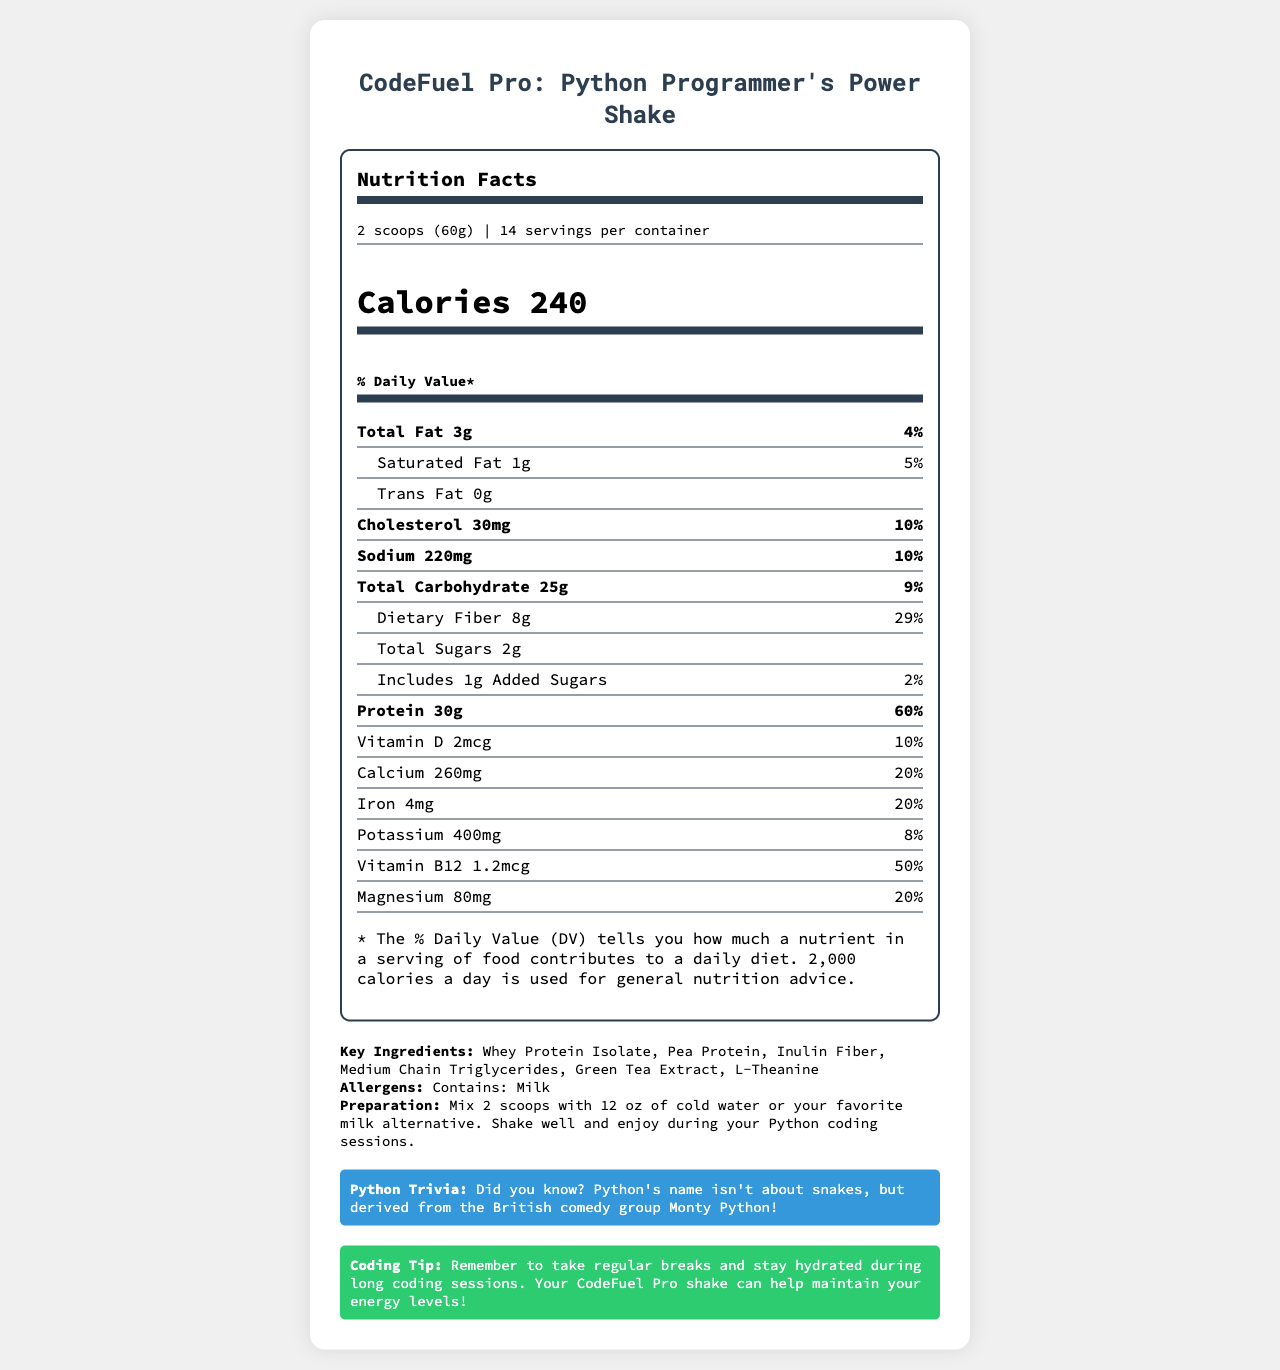what is the product name? The document title indicates the product name as "CodeFuel Pro: Python Programmer's Power Shake."
Answer: CodeFuel Pro: Python Programmer's Power Shake how many calories are in one serving? The document specifies that each serving contains 240 calories.
Answer: 240 how much protein does one serving contain? The nutrition facts section states that each serving contains 30 grams of protein.
Answer: 30g what is the serving size in grams? The serving size is listed as "2 scoops (60g)" in the document.
Answer: 60g how many servings are there in a container? The document mentions that there are 14 servings per container.
Answer: 14 what is the percentage daily value of dietary fiber per serving? The nutrition facts section states that dietary fiber in one serving is 29% of the daily value.
Answer: 29% what allergens does it contain? The document lists "Contains: Milk" under allergens.
Answer: Milk what is the recommended preparation method? A. Mix with water B. Heat in the microwave C. Add to a salad D. Just eat it dry The preparation method is "Mix 2 scoops with 12 oz of cold water or your favorite milk alternative. Shake well and enjoy during your Python coding sessions."
Answer: A which nutrient has the highest daily value percentage? A. Total Fat B. Vitamin B12 C. Protein D. Calcium Protein has a daily value percentage of 60%, which is the highest among the listed nutrients.
Answer: C does this product contain any added sugars? The nutrition facts indicate that there is 1g of added sugars per serving.
Answer: Yes is this product fortified with Vitamin D? The document states that the product contains 2mcg of Vitamin D, which is 10% of the daily value.
Answer: Yes can you determine how much polyunsaturated fat is in one serving? The document does not provide information on polyunsaturated fat content.
Answer: Cannot be determined summarize the main idea of the document The summary provides an overview of the nutrition facts, key ingredients, and additional information included in the document.
Answer: The document is a nutrition facts label for "CodeFuel Pro: Python Programmer's Power Shake," designed for long coding sessions. It emphasizes high protein (30g per serving) and fiber (8g per serving) content. Other nutritional details include calories, total fat, saturated fat, cholesterol, sodium, total carbohydrates, sugars, vitamins, and minerals. It also includes key ingredients, allergens, preparation instructions, a Python trivia fact, and a coding tip. 